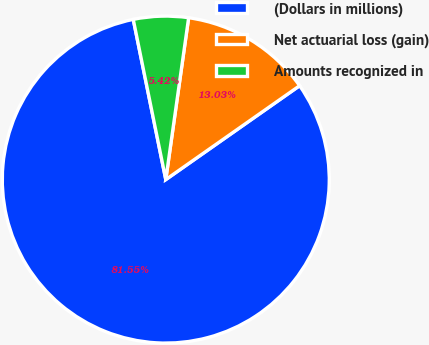<chart> <loc_0><loc_0><loc_500><loc_500><pie_chart><fcel>(Dollars in millions)<fcel>Net actuarial loss (gain)<fcel>Amounts recognized in<nl><fcel>81.54%<fcel>13.03%<fcel>5.42%<nl></chart> 